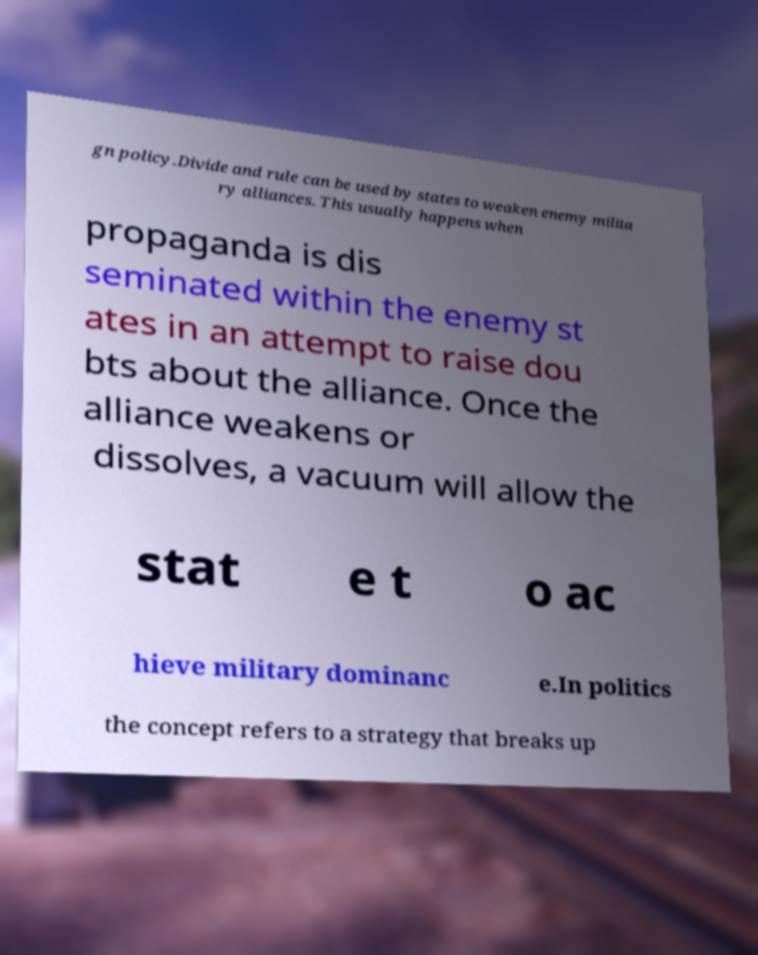Please identify and transcribe the text found in this image. gn policy.Divide and rule can be used by states to weaken enemy milita ry alliances. This usually happens when propaganda is dis seminated within the enemy st ates in an attempt to raise dou bts about the alliance. Once the alliance weakens or dissolves, a vacuum will allow the stat e t o ac hieve military dominanc e.In politics the concept refers to a strategy that breaks up 